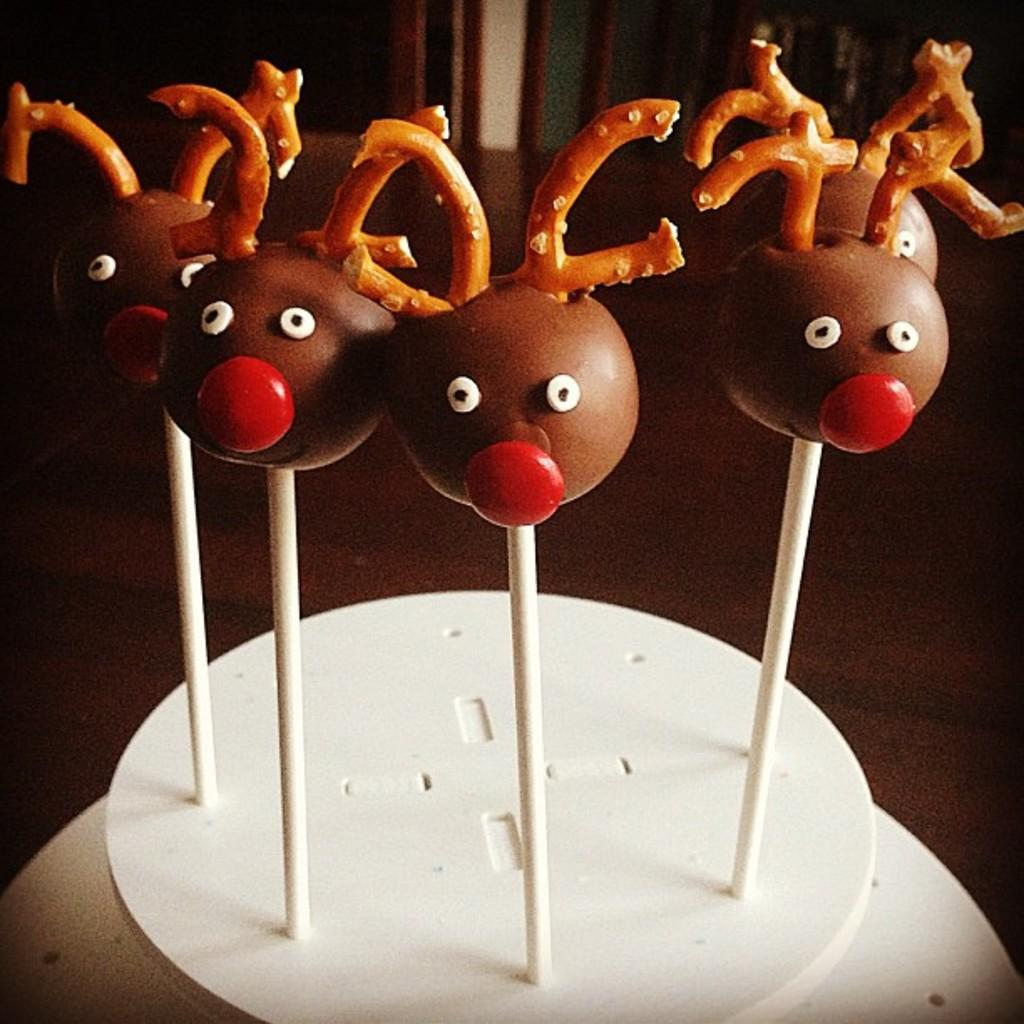What type of objects are the food items placed on in the image? The food items are on white colored objects. Can you describe the setting of the image? The ground is visible in the image, and there is a background present. How does the self-comforting passenger feel in the image? There is no passenger or self-comforting mentioned in the image; it only contains food items on white colored objects with a visible ground and background. 